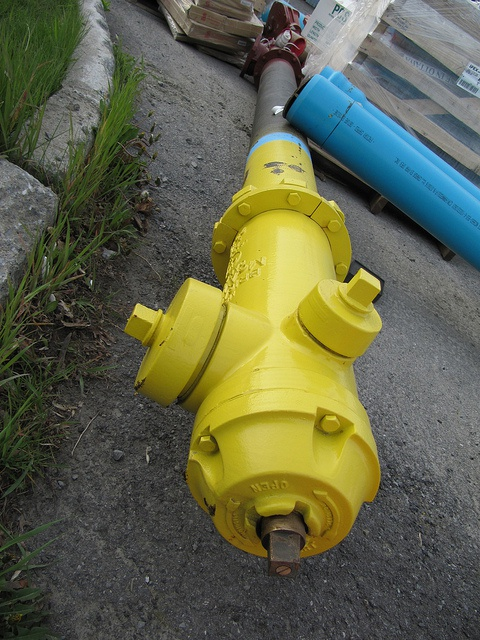Describe the objects in this image and their specific colors. I can see a fire hydrant in darkgreen, olive, and khaki tones in this image. 